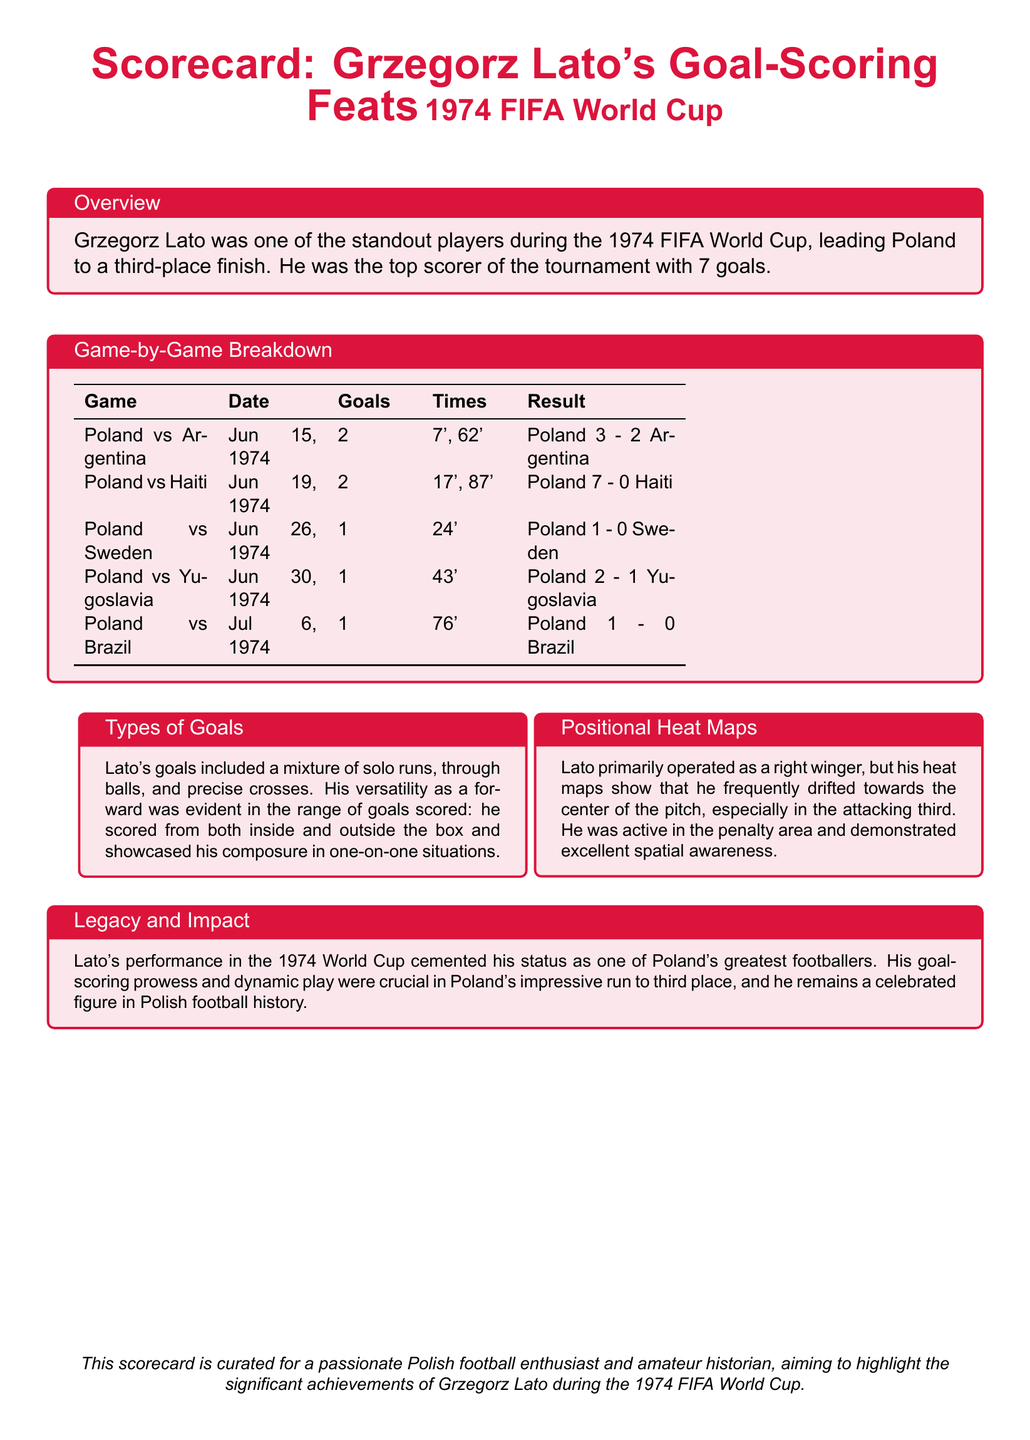What was Grzegorz Lato's total goal count in the tournament? The document states that Lato was the top scorer with 7 goals during the 1974 FIFA World Cup.
Answer: 7 goals How many goals did Lato score against Argentina? The game-by-game breakdown indicates that Lato scored 2 goals in the match against Argentina.
Answer: 2 goals What was the result of Poland vs Brazil? The game summary shows that Poland won the match against Brazil with a score of 1 - 0.
Answer: Poland 1 - 0 Brazil In which match did Lato score his first goal? According to the game-by-game breakdown, Lato scored his first goal on June 15, 1974, against Argentina.
Answer: Poland vs Argentina What types of goals did Lato score? The document mentions that Lato's goals included solo runs, through balls, and precise crosses.
Answer: Mixture of solo runs, through balls, and precise crosses What position did Lato primarily play during the tournament? The document states that Lato primarily operated as a right winger during the 1974 FIFA World Cup.
Answer: Right winger What was Lato's impact on Poland's overall performance? The legacy section highlights that Lato's performance was crucial in leading Poland to a third-place finish.
Answer: Third-place finish How many goals did Lato score against Haiti? The game-by-game breakdown lists that Lato scored 2 goals against Haiti.
Answer: 2 goals In which match did Lato score his last goal of the tournament? According to the game breakdown, Lato scored his last goal on July 6, 1974, against Brazil.
Answer: Poland vs Brazil 